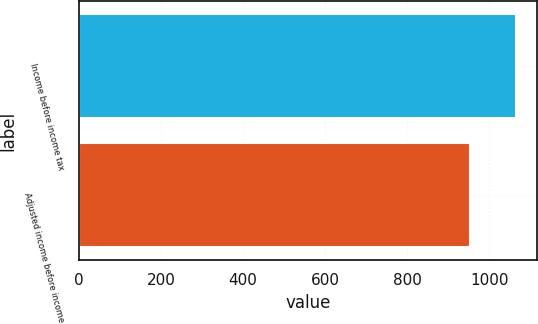Convert chart to OTSL. <chart><loc_0><loc_0><loc_500><loc_500><bar_chart><fcel>Income before income tax<fcel>Adjusted income before income<nl><fcel>1064<fcel>954<nl></chart> 